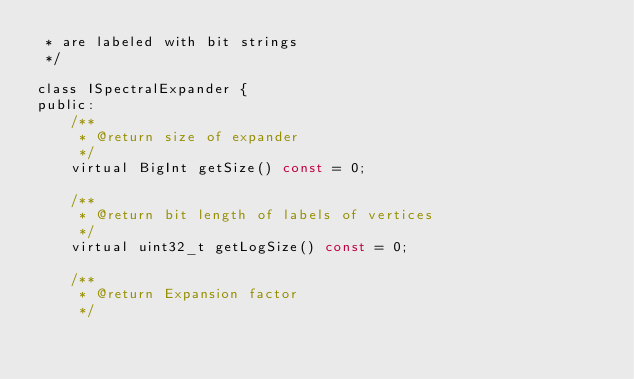Convert code to text. <code><loc_0><loc_0><loc_500><loc_500><_C_> * are labeled with bit strings
 */

class ISpectralExpander {
public:
    /**
     * @return size of expander
     */
    virtual BigInt getSize() const = 0;

    /**
     * @return bit length of labels of vertices
     */
    virtual uint32_t getLogSize() const = 0;

    /**
     * @return Expansion factor
     */</code> 